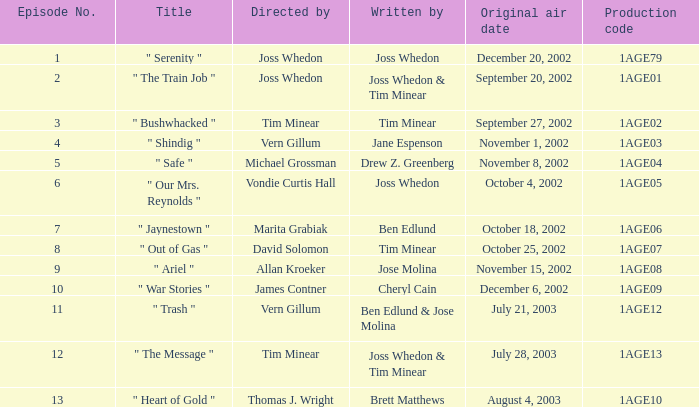Would you mind parsing the complete table? {'header': ['Episode No.', 'Title', 'Directed by', 'Written by', 'Original air date', 'Production code'], 'rows': [['1', '" Serenity "', 'Joss Whedon', 'Joss Whedon', 'December 20, 2002', '1AGE79'], ['2', '" The Train Job "', 'Joss Whedon', 'Joss Whedon & Tim Minear', 'September 20, 2002', '1AGE01'], ['3', '" Bushwhacked "', 'Tim Minear', 'Tim Minear', 'September 27, 2002', '1AGE02'], ['4', '" Shindig "', 'Vern Gillum', 'Jane Espenson', 'November 1, 2002', '1AGE03'], ['5', '" Safe "', 'Michael Grossman', 'Drew Z. Greenberg', 'November 8, 2002', '1AGE04'], ['6', '" Our Mrs. Reynolds "', 'Vondie Curtis Hall', 'Joss Whedon', 'October 4, 2002', '1AGE05'], ['7', '" Jaynestown "', 'Marita Grabiak', 'Ben Edlund', 'October 18, 2002', '1AGE06'], ['8', '" Out of Gas "', 'David Solomon', 'Tim Minear', 'October 25, 2002', '1AGE07'], ['9', '" Ariel "', 'Allan Kroeker', 'Jose Molina', 'November 15, 2002', '1AGE08'], ['10', '" War Stories "', 'James Contner', 'Cheryl Cain', 'December 6, 2002', '1AGE09'], ['11', '" Trash "', 'Vern Gillum', 'Ben Edlund & Jose Molina', 'July 21, 2003', '1AGE12'], ['12', '" The Message "', 'Tim Minear', 'Joss Whedon & Tim Minear', 'July 28, 2003', '1AGE13'], ['13', '" Heart of Gold "', 'Thomas J. Wright', 'Brett Matthews', 'August 4, 2003', '1AGE10']]} Who directed episode number 3? Tim Minear. 